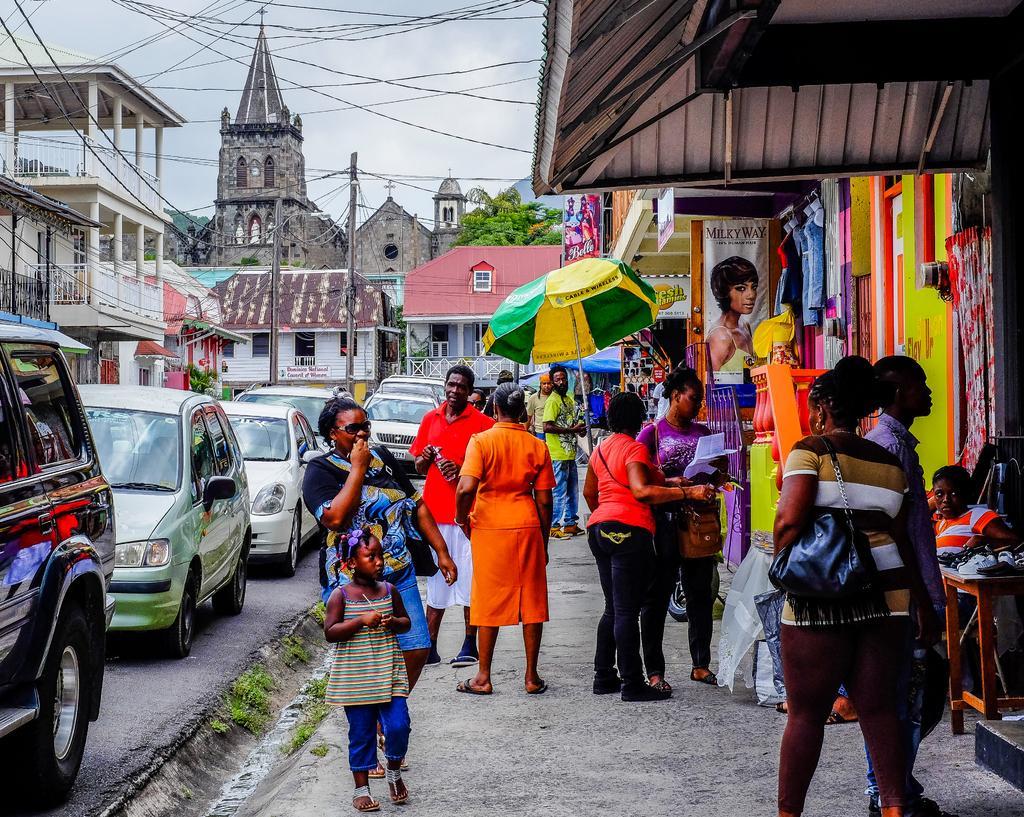In one or two sentences, can you explain what this image depicts? The image is taken on the road. On the right side of the image we can see people standing and there is a parasol. On the left there are cars on the road. In the background there are buildings and trees. At the top there is sky and wires. 